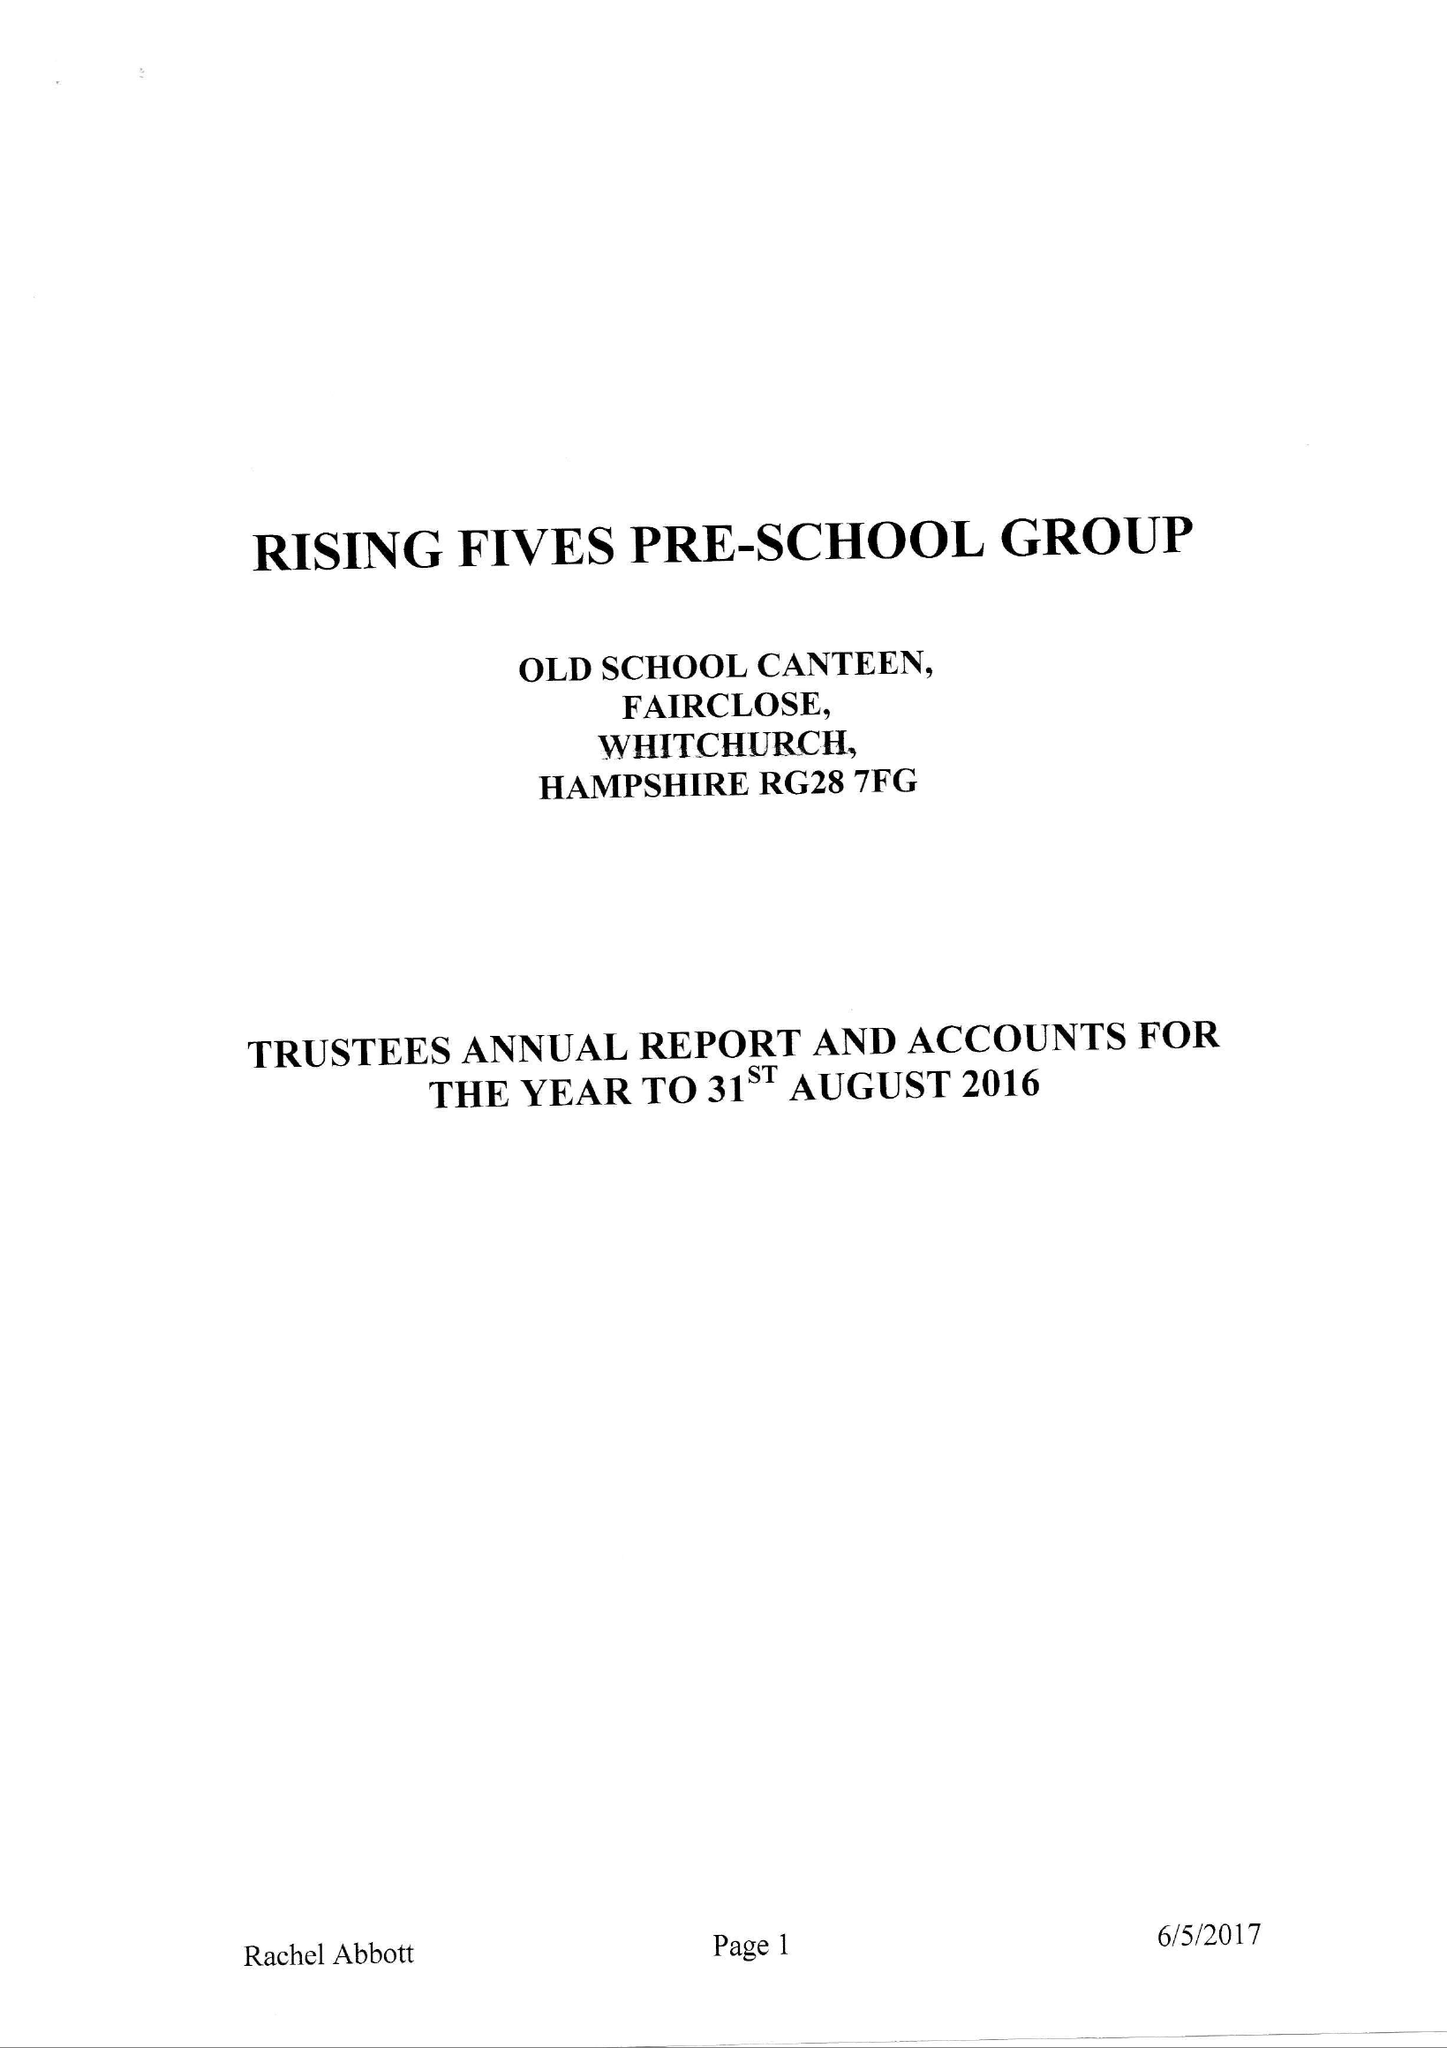What is the value for the address__street_line?
Answer the question using a single word or phrase. WELLS LANE 